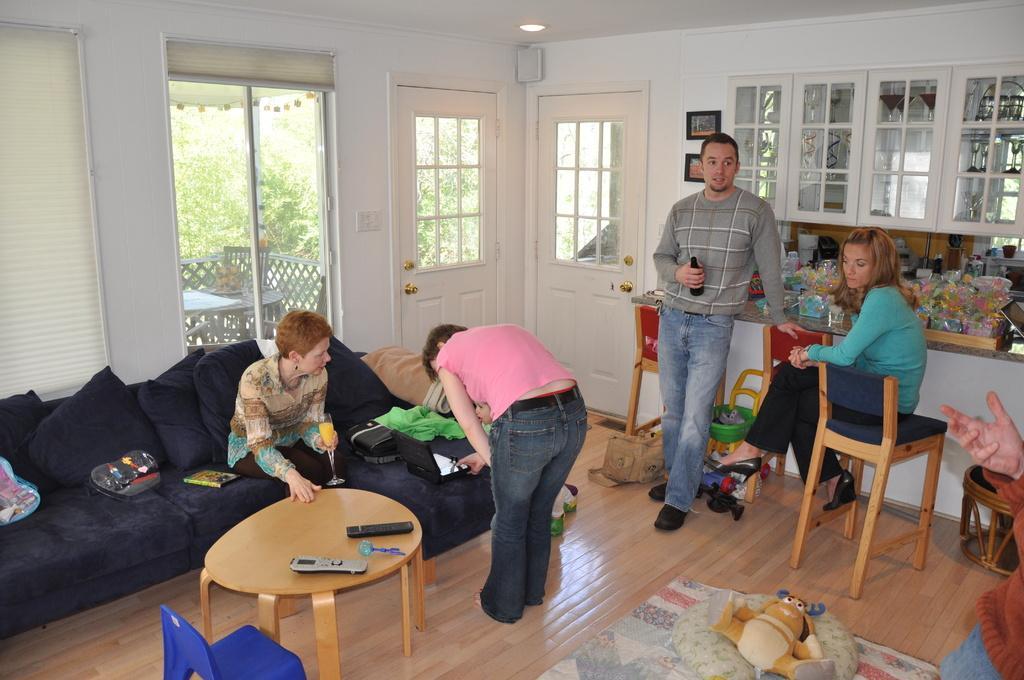How would you summarize this image in a sentence or two? On the table there is remote,toy and on the sofa woman,book,cloth. girl is sitting on the chair,man standing holding bottle in the back there is glass,here there are two doors,here there are toys 